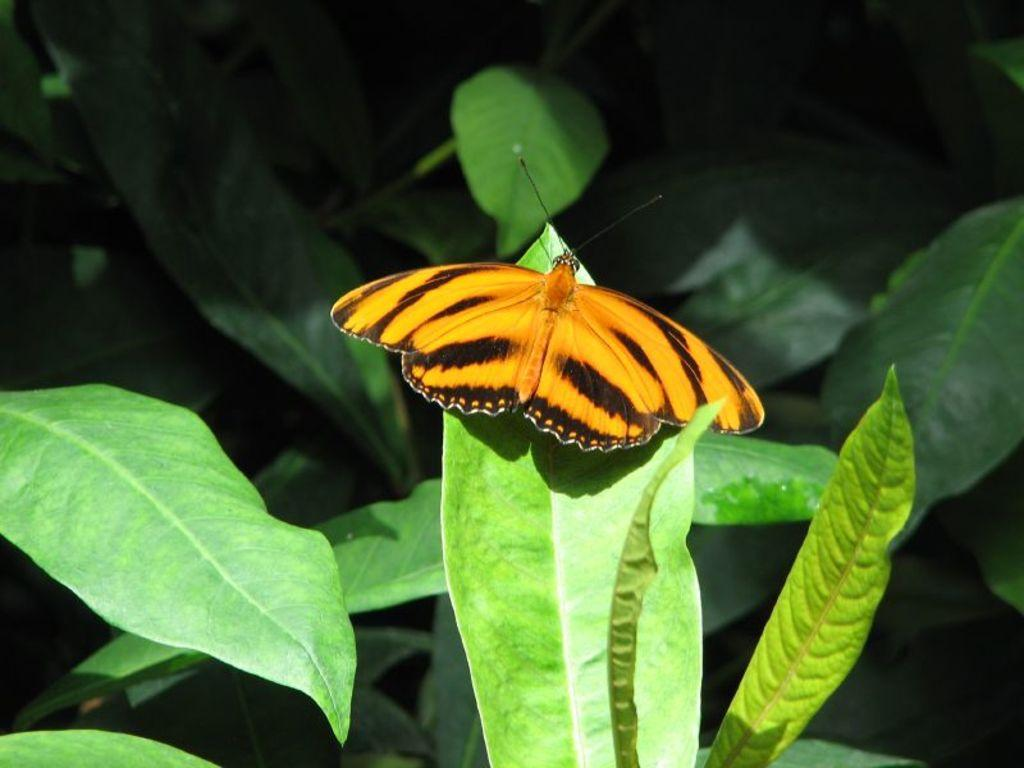What type of insect is in the image? There is a brown color butterfly in the image. Where is the butterfly located? The butterfly is on a leaf. What is the color of the leaf the butterfly is on? The leaf is part of a tree with green color leaves. What can be observed about the background of the image? The background of the image is dark in color. What type of design can be seen on the mountain in the image? There is no mountain present in the image; it features a brown color butterfly on a leaf. Is it raining in the image? There is no indication of rain in the image, as it focuses on a butterfly on a leaf with a dark background. 